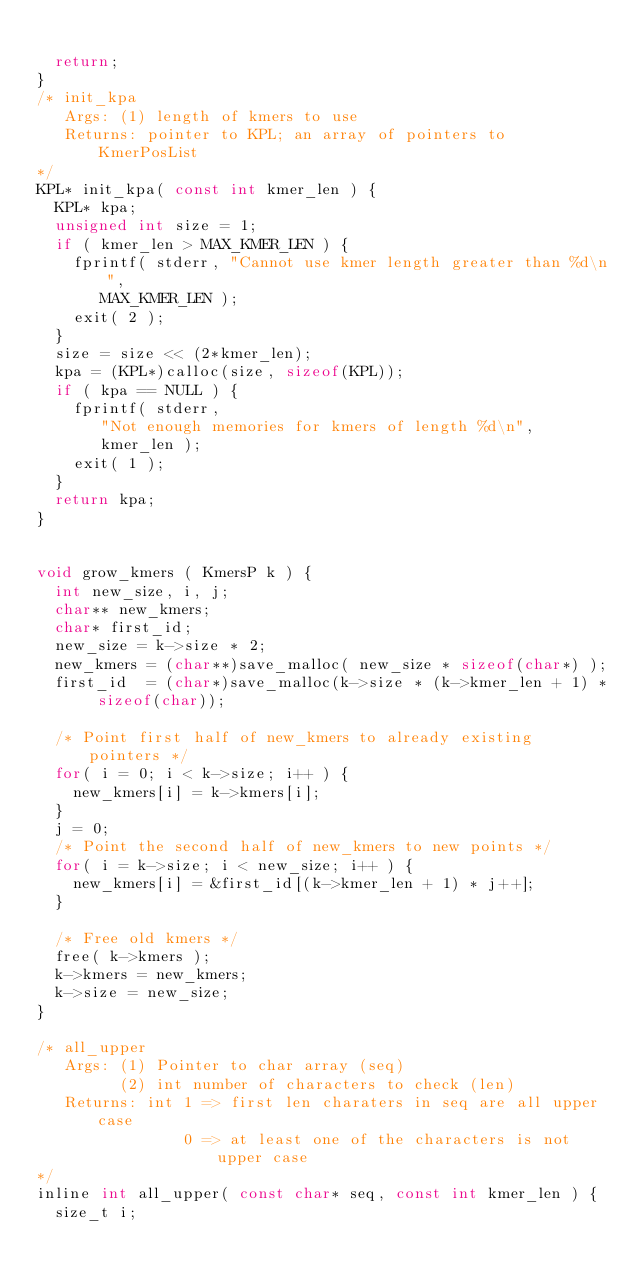<code> <loc_0><loc_0><loc_500><loc_500><_C_>
  return;
}
/* init_kpa
   Args: (1) length of kmers to use
   Returns: pointer to KPL; an array of pointers to KmerPosList
*/
KPL* init_kpa( const int kmer_len ) {
  KPL* kpa;
  unsigned int size = 1;
  if ( kmer_len > MAX_KMER_LEN ) {
    fprintf( stderr, "Cannot use kmer length greater than %d\n",
	     MAX_KMER_LEN );
    exit( 2 );
  }
  size = size << (2*kmer_len);
  kpa = (KPL*)calloc(size, sizeof(KPL));
  if ( kpa == NULL ) {
    fprintf( stderr,
	     "Not enough memories for kmers of length %d\n",
	     kmer_len );
    exit( 1 );
  }
  return kpa;
}


void grow_kmers ( KmersP k ) {
  int new_size, i, j;
  char** new_kmers;
  char* first_id;
  new_size = k->size * 2;
  new_kmers = (char**)save_malloc( new_size * sizeof(char*) );
  first_id  = (char*)save_malloc(k->size * (k->kmer_len + 1) * sizeof(char));

  /* Point first half of new_kmers to already existing pointers */
  for( i = 0; i < k->size; i++ ) {
    new_kmers[i] = k->kmers[i];
  }
  j = 0;
  /* Point the second half of new_kmers to new points */
  for( i = k->size; i < new_size; i++ ) {
    new_kmers[i] = &first_id[(k->kmer_len + 1) * j++];
  }

  /* Free old kmers */
  free( k->kmers );
  k->kmers = new_kmers;
  k->size = new_size;
}

/* all_upper
   Args: (1) Pointer to char array (seq)
         (2) int number of characters to check (len)
   Returns: int 1 => first len charaters in seq are all upper case
                0 => at least one of the characters is not upper case
*/
inline int all_upper( const char* seq, const int kmer_len ) {
  size_t i;</code> 